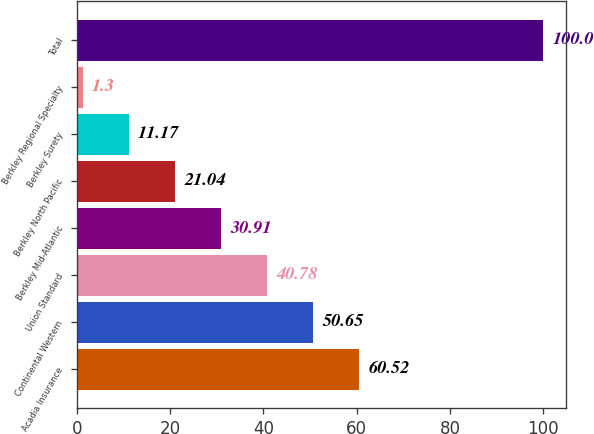<chart> <loc_0><loc_0><loc_500><loc_500><bar_chart><fcel>Acadia Insurance<fcel>Continental Western<fcel>Union Standard<fcel>Berkley Mid-Atlantic<fcel>Berkley North Pacific<fcel>Berkley Surety<fcel>Berkley Regional Specialty<fcel>Total<nl><fcel>60.52<fcel>50.65<fcel>40.78<fcel>30.91<fcel>21.04<fcel>11.17<fcel>1.3<fcel>100<nl></chart> 